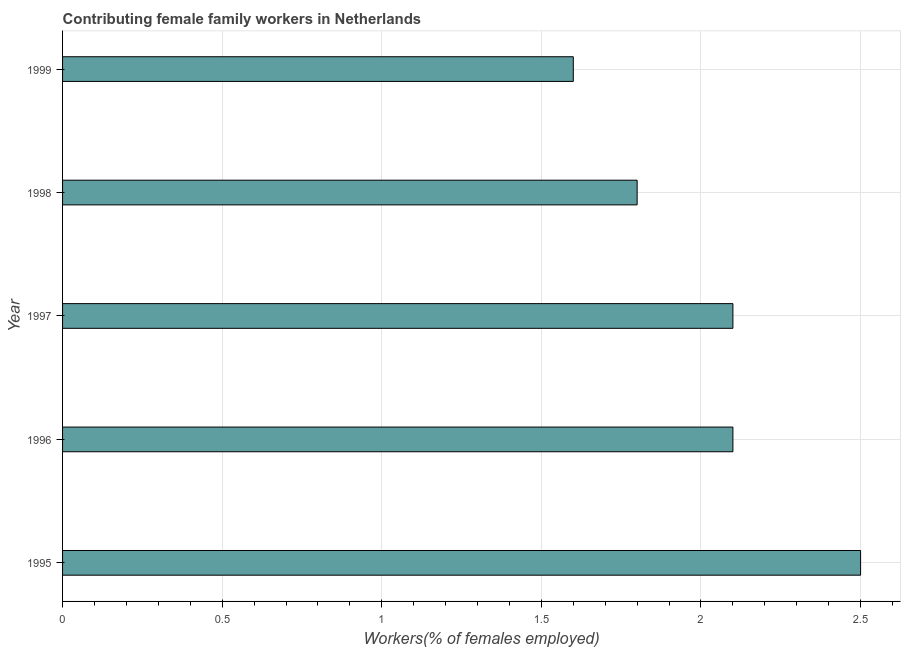Does the graph contain any zero values?
Give a very brief answer. No. Does the graph contain grids?
Your response must be concise. Yes. What is the title of the graph?
Make the answer very short. Contributing female family workers in Netherlands. What is the label or title of the X-axis?
Provide a short and direct response. Workers(% of females employed). What is the label or title of the Y-axis?
Offer a very short reply. Year. What is the contributing female family workers in 1996?
Your answer should be very brief. 2.1. Across all years, what is the maximum contributing female family workers?
Give a very brief answer. 2.5. Across all years, what is the minimum contributing female family workers?
Provide a short and direct response. 1.6. In which year was the contributing female family workers minimum?
Make the answer very short. 1999. What is the sum of the contributing female family workers?
Keep it short and to the point. 10.1. What is the average contributing female family workers per year?
Your answer should be compact. 2.02. What is the median contributing female family workers?
Offer a very short reply. 2.1. In how many years, is the contributing female family workers greater than 2.5 %?
Your answer should be very brief. 0. What is the ratio of the contributing female family workers in 1998 to that in 1999?
Provide a succinct answer. 1.12. Is the difference between the contributing female family workers in 1996 and 1997 greater than the difference between any two years?
Offer a very short reply. No. Is the sum of the contributing female family workers in 1997 and 1998 greater than the maximum contributing female family workers across all years?
Provide a short and direct response. Yes. What is the difference between the highest and the lowest contributing female family workers?
Offer a very short reply. 0.9. In how many years, is the contributing female family workers greater than the average contributing female family workers taken over all years?
Your answer should be very brief. 3. How many bars are there?
Your answer should be very brief. 5. How many years are there in the graph?
Your answer should be very brief. 5. What is the Workers(% of females employed) in 1996?
Give a very brief answer. 2.1. What is the Workers(% of females employed) of 1997?
Make the answer very short. 2.1. What is the Workers(% of females employed) in 1998?
Offer a terse response. 1.8. What is the Workers(% of females employed) of 1999?
Make the answer very short. 1.6. What is the difference between the Workers(% of females employed) in 1995 and 1996?
Offer a terse response. 0.4. What is the difference between the Workers(% of females employed) in 1995 and 1998?
Offer a very short reply. 0.7. What is the difference between the Workers(% of females employed) in 1996 and 1997?
Your answer should be very brief. 0. What is the difference between the Workers(% of females employed) in 1996 and 1998?
Keep it short and to the point. 0.3. What is the difference between the Workers(% of females employed) in 1996 and 1999?
Your response must be concise. 0.5. What is the difference between the Workers(% of females employed) in 1997 and 1998?
Keep it short and to the point. 0.3. What is the difference between the Workers(% of females employed) in 1998 and 1999?
Your answer should be very brief. 0.2. What is the ratio of the Workers(% of females employed) in 1995 to that in 1996?
Your answer should be very brief. 1.19. What is the ratio of the Workers(% of females employed) in 1995 to that in 1997?
Offer a very short reply. 1.19. What is the ratio of the Workers(% of females employed) in 1995 to that in 1998?
Your response must be concise. 1.39. What is the ratio of the Workers(% of females employed) in 1995 to that in 1999?
Provide a succinct answer. 1.56. What is the ratio of the Workers(% of females employed) in 1996 to that in 1997?
Keep it short and to the point. 1. What is the ratio of the Workers(% of females employed) in 1996 to that in 1998?
Your answer should be very brief. 1.17. What is the ratio of the Workers(% of females employed) in 1996 to that in 1999?
Ensure brevity in your answer.  1.31. What is the ratio of the Workers(% of females employed) in 1997 to that in 1998?
Provide a succinct answer. 1.17. What is the ratio of the Workers(% of females employed) in 1997 to that in 1999?
Make the answer very short. 1.31. 